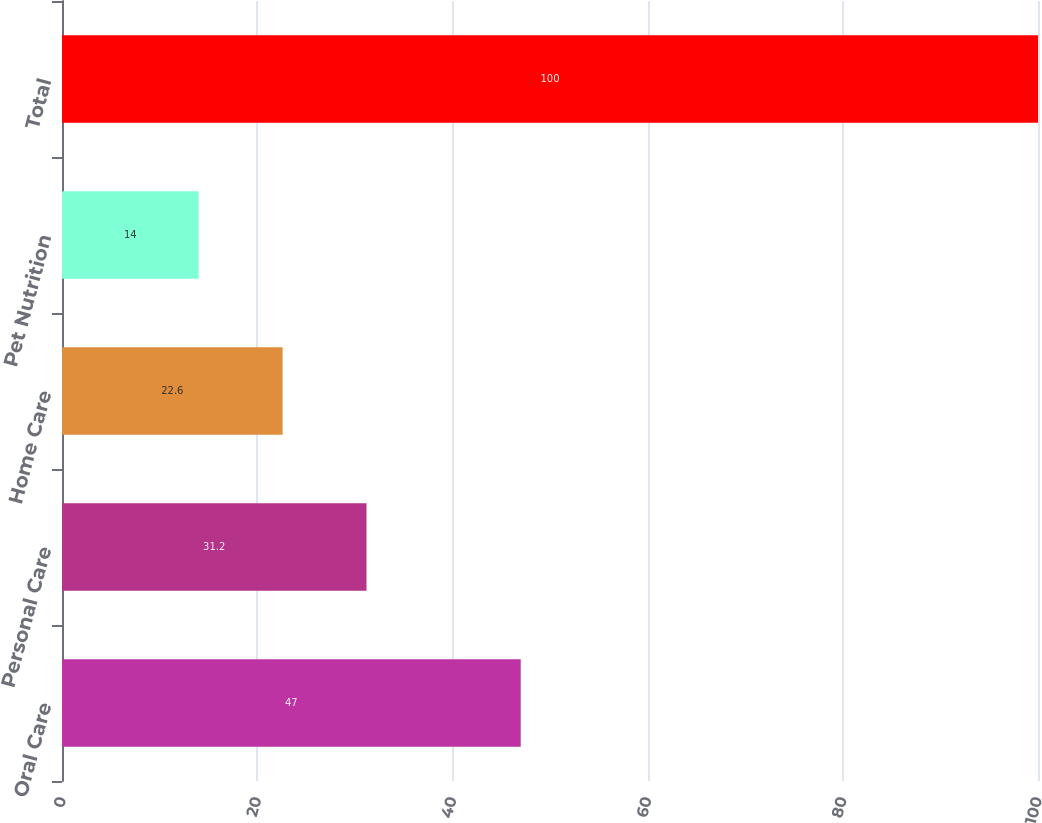<chart> <loc_0><loc_0><loc_500><loc_500><bar_chart><fcel>Oral Care<fcel>Personal Care<fcel>Home Care<fcel>Pet Nutrition<fcel>Total<nl><fcel>47<fcel>31.2<fcel>22.6<fcel>14<fcel>100<nl></chart> 